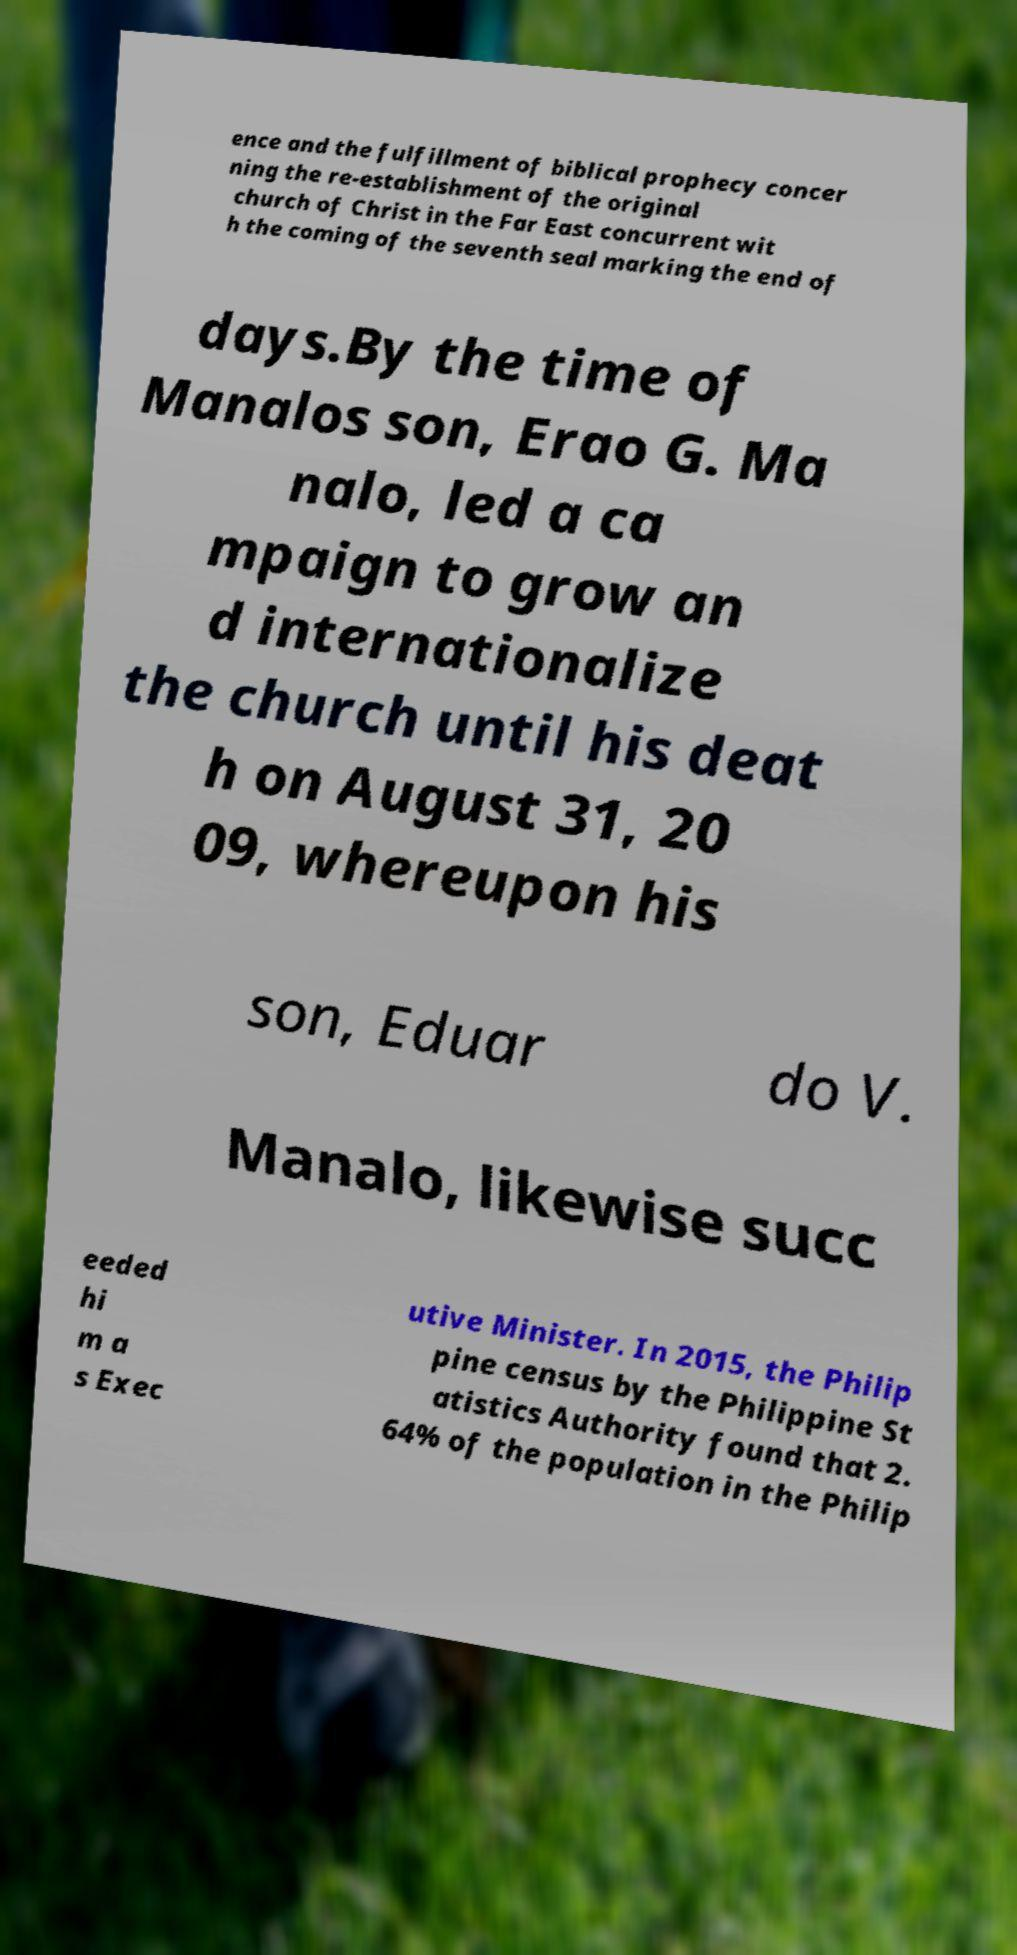What messages or text are displayed in this image? I need them in a readable, typed format. ence and the fulfillment of biblical prophecy concer ning the re-establishment of the original church of Christ in the Far East concurrent wit h the coming of the seventh seal marking the end of days.By the time of Manalos son, Erao G. Ma nalo, led a ca mpaign to grow an d internationalize the church until his deat h on August 31, 20 09, whereupon his son, Eduar do V. Manalo, likewise succ eeded hi m a s Exec utive Minister. In 2015, the Philip pine census by the Philippine St atistics Authority found that 2. 64% of the population in the Philip 